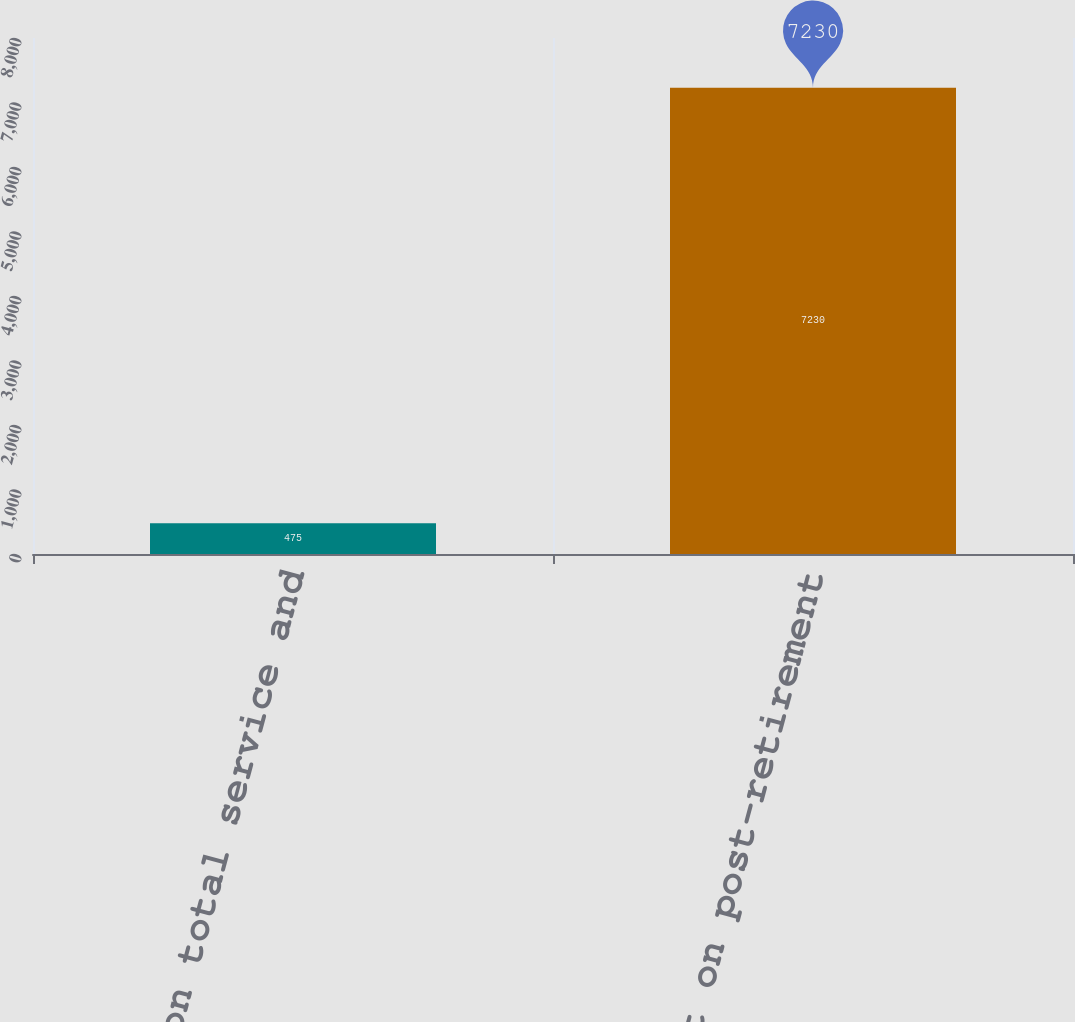Convert chart. <chart><loc_0><loc_0><loc_500><loc_500><bar_chart><fcel>Effect on total service and<fcel>Effect on post-retirement<nl><fcel>475<fcel>7230<nl></chart> 